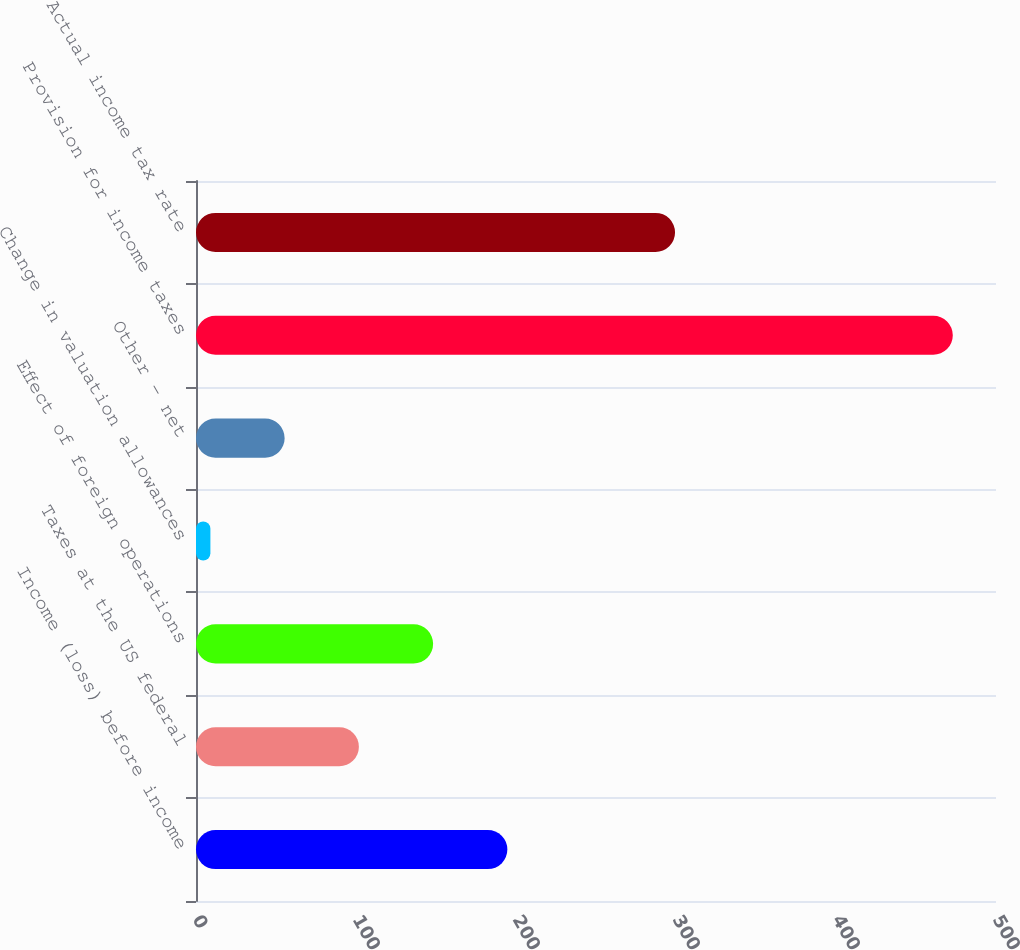Convert chart to OTSL. <chart><loc_0><loc_0><loc_500><loc_500><bar_chart><fcel>Income (loss) before income<fcel>Taxes at the US federal<fcel>Effect of foreign operations<fcel>Change in valuation allowances<fcel>Other - net<fcel>Provision for income taxes<fcel>Actual income tax rate<nl><fcel>194.6<fcel>101.8<fcel>148.2<fcel>9<fcel>55.4<fcel>473<fcel>299.4<nl></chart> 